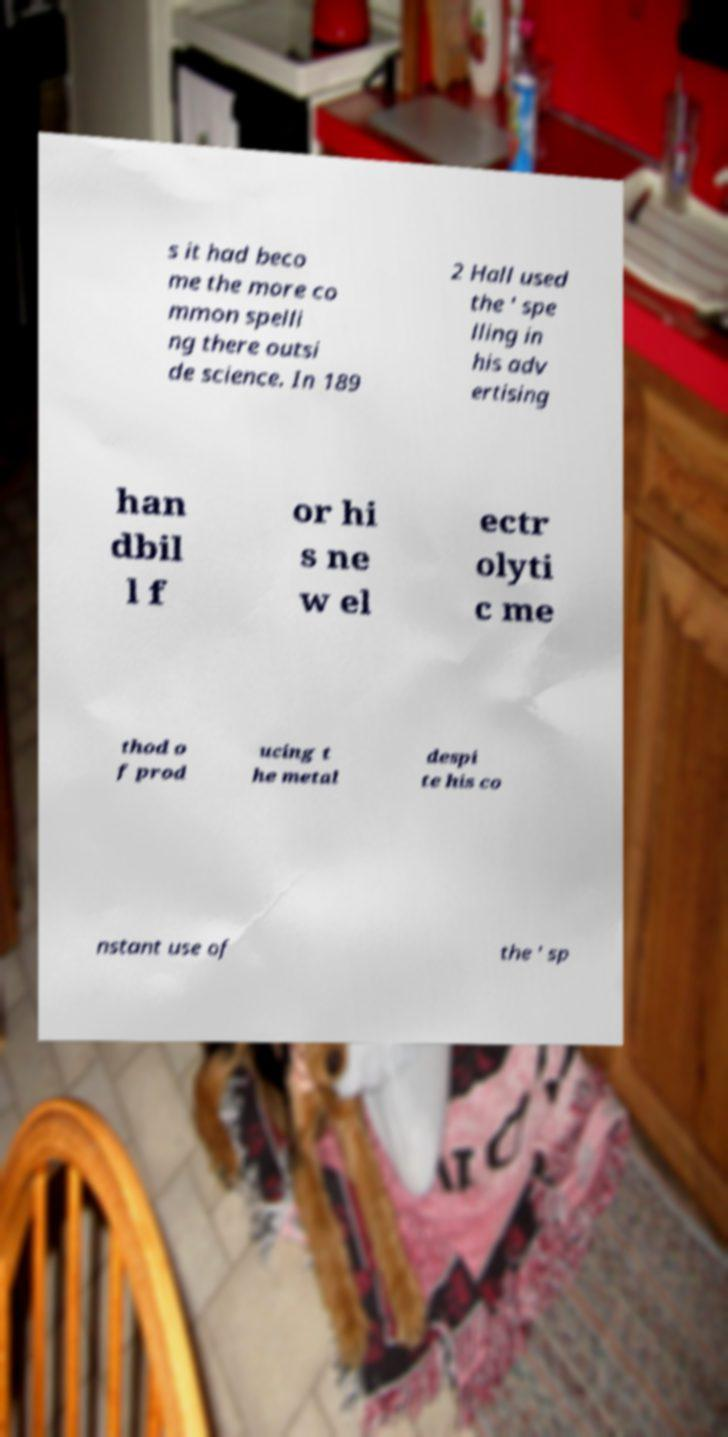I need the written content from this picture converted into text. Can you do that? s it had beco me the more co mmon spelli ng there outsi de science. In 189 2 Hall used the ' spe lling in his adv ertising han dbil l f or hi s ne w el ectr olyti c me thod o f prod ucing t he metal despi te his co nstant use of the ' sp 